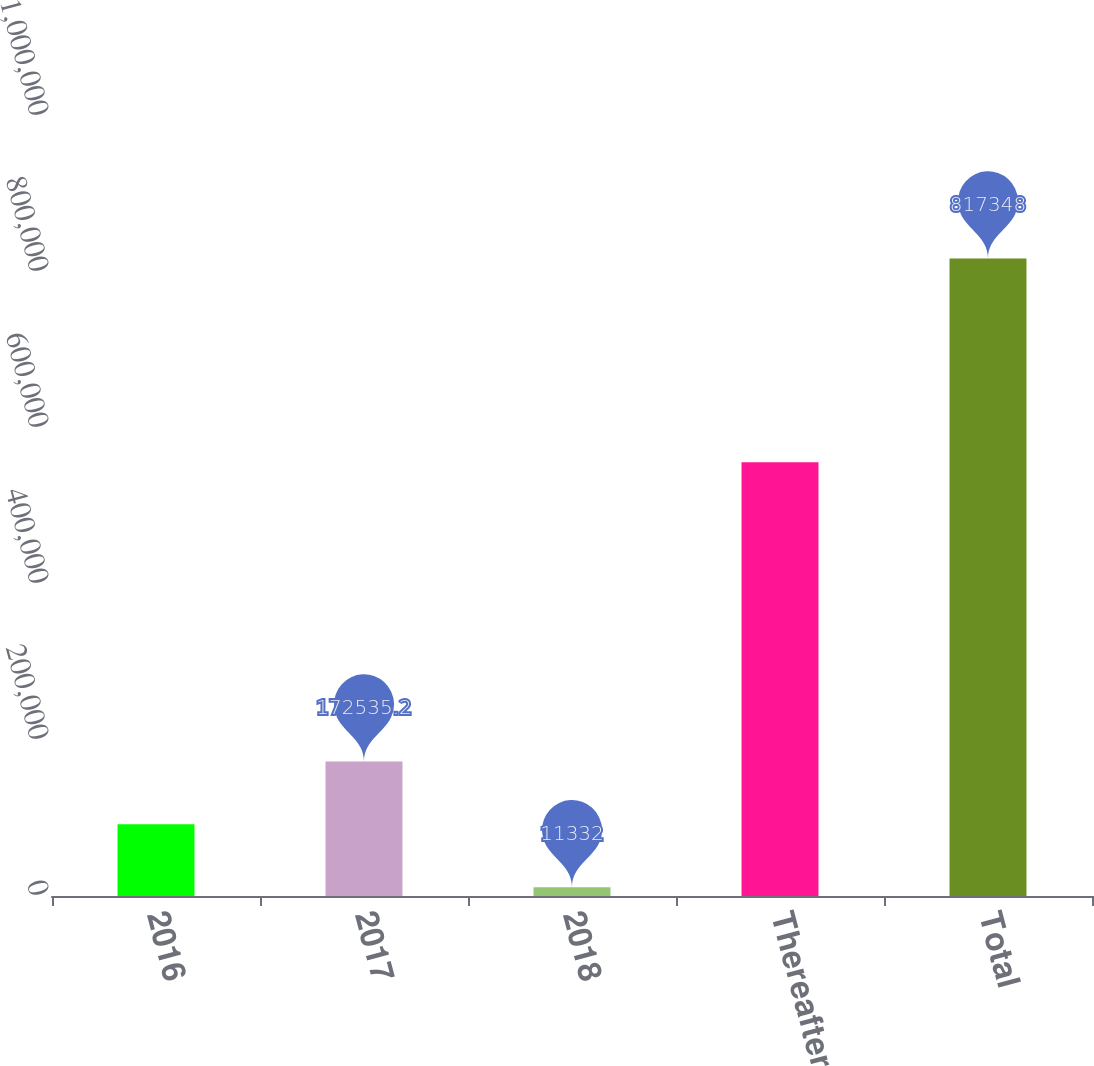Convert chart. <chart><loc_0><loc_0><loc_500><loc_500><bar_chart><fcel>2016<fcel>2017<fcel>2018<fcel>Thereafter<fcel>Total<nl><fcel>91933.6<fcel>172535<fcel>11332<fcel>556168<fcel>817348<nl></chart> 